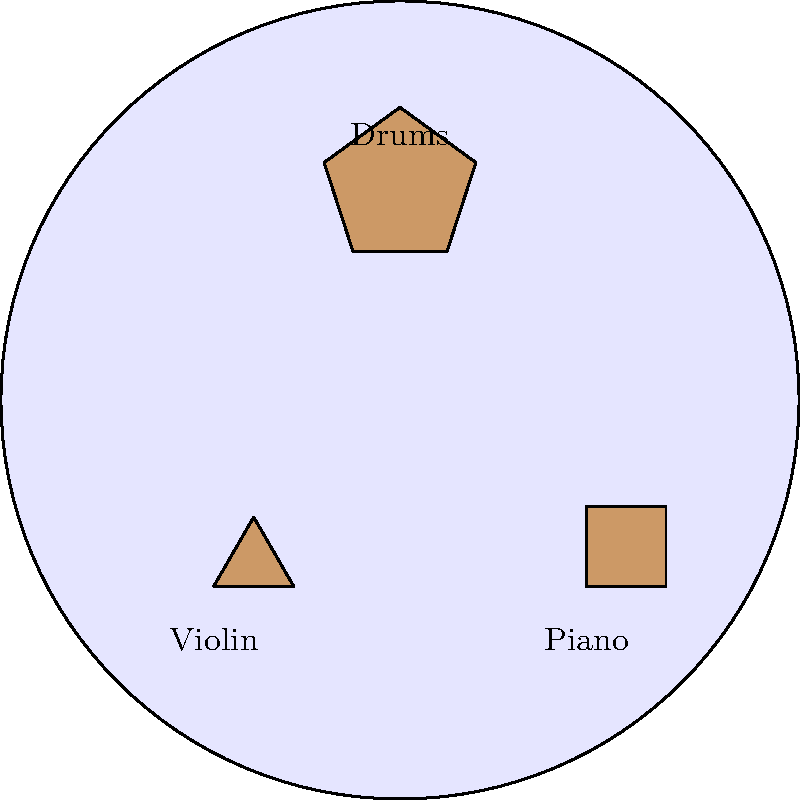In a Dardust-inspired orchestral arrangement, three instruments are represented by geometric shapes: a triangle (violin), a square (piano), and a pentagon (drums). If we apply a rotation of 72° clockwise followed by a reflection across the vertical axis to the entire arrangement, how many of these instruments will be in their original positions? Let's approach this step-by-step:

1) First, let's consider the rotational symmetry of each shape:
   - Triangle: 120° (3-fold rotational symmetry)
   - Square: 90° (4-fold rotational symmetry)
   - Pentagon: 72° (5-fold rotational symmetry)

2) The rotation of 72° clockwise:
   - The triangle and square will move to new positions.
   - The pentagon will remain in the same position due to its 72° rotational symmetry.

3) The reflection across the vertical axis:
   - This will flip the entire arrangement horizontally.
   - The triangle and square will move to new positions again.
   - The pentagon, being symmetric about the vertical axis, will remain in the same position.

4) Combined effect:
   - The triangle and square have moved twice and are not in their original positions.
   - The pentagon, having stayed in place through both transformations, remains in its original position.

5) Therefore, out of the three instruments, only the drums (pentagon) will be in its original position after these transformations.
Answer: 1 (the drums) 